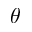<formula> <loc_0><loc_0><loc_500><loc_500>\theta</formula> 